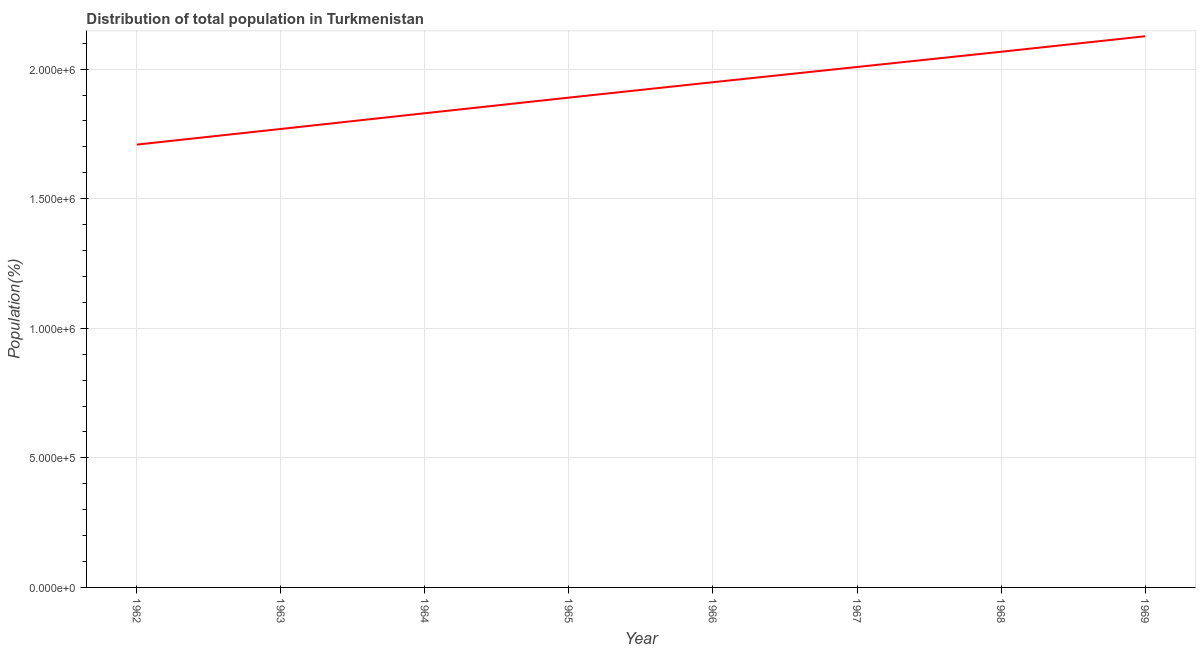What is the population in 1965?
Your answer should be compact. 1.89e+06. Across all years, what is the maximum population?
Your answer should be compact. 2.13e+06. Across all years, what is the minimum population?
Your response must be concise. 1.71e+06. In which year was the population maximum?
Give a very brief answer. 1969. In which year was the population minimum?
Make the answer very short. 1962. What is the sum of the population?
Provide a short and direct response. 1.53e+07. What is the difference between the population in 1966 and 1968?
Your answer should be compact. -1.17e+05. What is the average population per year?
Keep it short and to the point. 1.92e+06. What is the median population?
Provide a succinct answer. 1.92e+06. Do a majority of the years between 1968 and 1962 (inclusive) have population greater than 700000 %?
Make the answer very short. Yes. What is the ratio of the population in 1963 to that in 1966?
Offer a terse response. 0.91. Is the population in 1967 less than that in 1969?
Your answer should be compact. Yes. Is the difference between the population in 1966 and 1968 greater than the difference between any two years?
Provide a succinct answer. No. What is the difference between the highest and the second highest population?
Your answer should be compact. 5.99e+04. Is the sum of the population in 1967 and 1969 greater than the maximum population across all years?
Your answer should be compact. Yes. What is the difference between the highest and the lowest population?
Your answer should be compact. 4.18e+05. In how many years, is the population greater than the average population taken over all years?
Ensure brevity in your answer.  4. Does the population monotonically increase over the years?
Provide a succinct answer. Yes. How many lines are there?
Give a very brief answer. 1. What is the difference between two consecutive major ticks on the Y-axis?
Offer a very short reply. 5.00e+05. Does the graph contain any zero values?
Your answer should be very brief. No. What is the title of the graph?
Your answer should be compact. Distribution of total population in Turkmenistan . What is the label or title of the Y-axis?
Your answer should be very brief. Population(%). What is the Population(%) in 1962?
Your answer should be compact. 1.71e+06. What is the Population(%) of 1963?
Provide a succinct answer. 1.77e+06. What is the Population(%) of 1964?
Your response must be concise. 1.83e+06. What is the Population(%) in 1965?
Your response must be concise. 1.89e+06. What is the Population(%) in 1966?
Offer a very short reply. 1.95e+06. What is the Population(%) in 1967?
Your response must be concise. 2.01e+06. What is the Population(%) in 1968?
Make the answer very short. 2.07e+06. What is the Population(%) of 1969?
Your answer should be very brief. 2.13e+06. What is the difference between the Population(%) in 1962 and 1963?
Your answer should be very brief. -6.03e+04. What is the difference between the Population(%) in 1962 and 1964?
Provide a succinct answer. -1.21e+05. What is the difference between the Population(%) in 1962 and 1965?
Your answer should be compact. -1.81e+05. What is the difference between the Population(%) in 1962 and 1966?
Give a very brief answer. -2.41e+05. What is the difference between the Population(%) in 1962 and 1967?
Ensure brevity in your answer.  -2.99e+05. What is the difference between the Population(%) in 1962 and 1968?
Your answer should be compact. -3.58e+05. What is the difference between the Population(%) in 1962 and 1969?
Offer a very short reply. -4.18e+05. What is the difference between the Population(%) in 1963 and 1964?
Provide a short and direct response. -6.07e+04. What is the difference between the Population(%) in 1963 and 1965?
Keep it short and to the point. -1.21e+05. What is the difference between the Population(%) in 1963 and 1966?
Your answer should be very brief. -1.80e+05. What is the difference between the Population(%) in 1963 and 1967?
Provide a succinct answer. -2.39e+05. What is the difference between the Population(%) in 1963 and 1968?
Give a very brief answer. -2.98e+05. What is the difference between the Population(%) in 1963 and 1969?
Your answer should be very brief. -3.58e+05. What is the difference between the Population(%) in 1964 and 1965?
Your answer should be compact. -6.03e+04. What is the difference between the Population(%) in 1964 and 1966?
Offer a very short reply. -1.20e+05. What is the difference between the Population(%) in 1964 and 1967?
Ensure brevity in your answer.  -1.78e+05. What is the difference between the Population(%) in 1964 and 1968?
Offer a terse response. -2.37e+05. What is the difference between the Population(%) in 1964 and 1969?
Your answer should be very brief. -2.97e+05. What is the difference between the Population(%) in 1965 and 1966?
Provide a short and direct response. -5.94e+04. What is the difference between the Population(%) in 1965 and 1967?
Give a very brief answer. -1.18e+05. What is the difference between the Population(%) in 1965 and 1968?
Your answer should be very brief. -1.77e+05. What is the difference between the Population(%) in 1965 and 1969?
Your answer should be compact. -2.37e+05. What is the difference between the Population(%) in 1966 and 1967?
Provide a short and direct response. -5.87e+04. What is the difference between the Population(%) in 1966 and 1968?
Your response must be concise. -1.17e+05. What is the difference between the Population(%) in 1966 and 1969?
Make the answer very short. -1.77e+05. What is the difference between the Population(%) in 1967 and 1968?
Keep it short and to the point. -5.87e+04. What is the difference between the Population(%) in 1967 and 1969?
Keep it short and to the point. -1.19e+05. What is the difference between the Population(%) in 1968 and 1969?
Your answer should be very brief. -5.99e+04. What is the ratio of the Population(%) in 1962 to that in 1964?
Keep it short and to the point. 0.93. What is the ratio of the Population(%) in 1962 to that in 1965?
Provide a succinct answer. 0.9. What is the ratio of the Population(%) in 1962 to that in 1966?
Ensure brevity in your answer.  0.88. What is the ratio of the Population(%) in 1962 to that in 1967?
Your answer should be very brief. 0.85. What is the ratio of the Population(%) in 1962 to that in 1968?
Ensure brevity in your answer.  0.83. What is the ratio of the Population(%) in 1962 to that in 1969?
Provide a short and direct response. 0.8. What is the ratio of the Population(%) in 1963 to that in 1964?
Your answer should be very brief. 0.97. What is the ratio of the Population(%) in 1963 to that in 1965?
Your response must be concise. 0.94. What is the ratio of the Population(%) in 1963 to that in 1966?
Ensure brevity in your answer.  0.91. What is the ratio of the Population(%) in 1963 to that in 1967?
Keep it short and to the point. 0.88. What is the ratio of the Population(%) in 1963 to that in 1968?
Make the answer very short. 0.86. What is the ratio of the Population(%) in 1963 to that in 1969?
Provide a succinct answer. 0.83. What is the ratio of the Population(%) in 1964 to that in 1966?
Your answer should be very brief. 0.94. What is the ratio of the Population(%) in 1964 to that in 1967?
Make the answer very short. 0.91. What is the ratio of the Population(%) in 1964 to that in 1968?
Offer a very short reply. 0.89. What is the ratio of the Population(%) in 1964 to that in 1969?
Ensure brevity in your answer.  0.86. What is the ratio of the Population(%) in 1965 to that in 1967?
Make the answer very short. 0.94. What is the ratio of the Population(%) in 1965 to that in 1968?
Offer a very short reply. 0.91. What is the ratio of the Population(%) in 1965 to that in 1969?
Your answer should be very brief. 0.89. What is the ratio of the Population(%) in 1966 to that in 1968?
Provide a short and direct response. 0.94. What is the ratio of the Population(%) in 1966 to that in 1969?
Offer a very short reply. 0.92. What is the ratio of the Population(%) in 1967 to that in 1969?
Give a very brief answer. 0.94. 